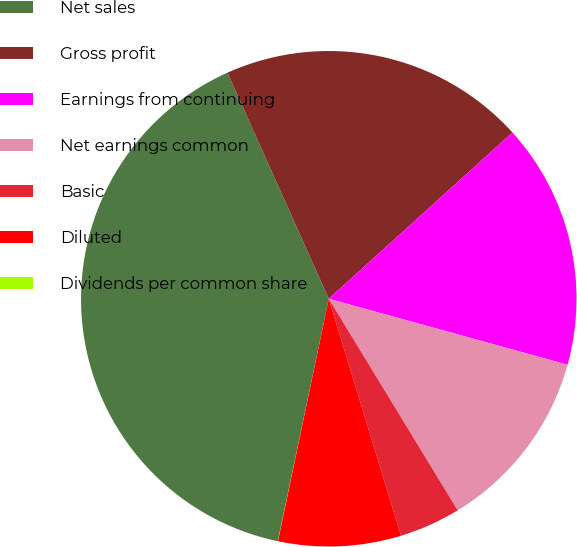Convert chart to OTSL. <chart><loc_0><loc_0><loc_500><loc_500><pie_chart><fcel>Net sales<fcel>Gross profit<fcel>Earnings from continuing<fcel>Net earnings common<fcel>Basic<fcel>Diluted<fcel>Dividends per common share<nl><fcel>39.99%<fcel>20.0%<fcel>16.0%<fcel>12.0%<fcel>4.0%<fcel>8.0%<fcel>0.01%<nl></chart> 